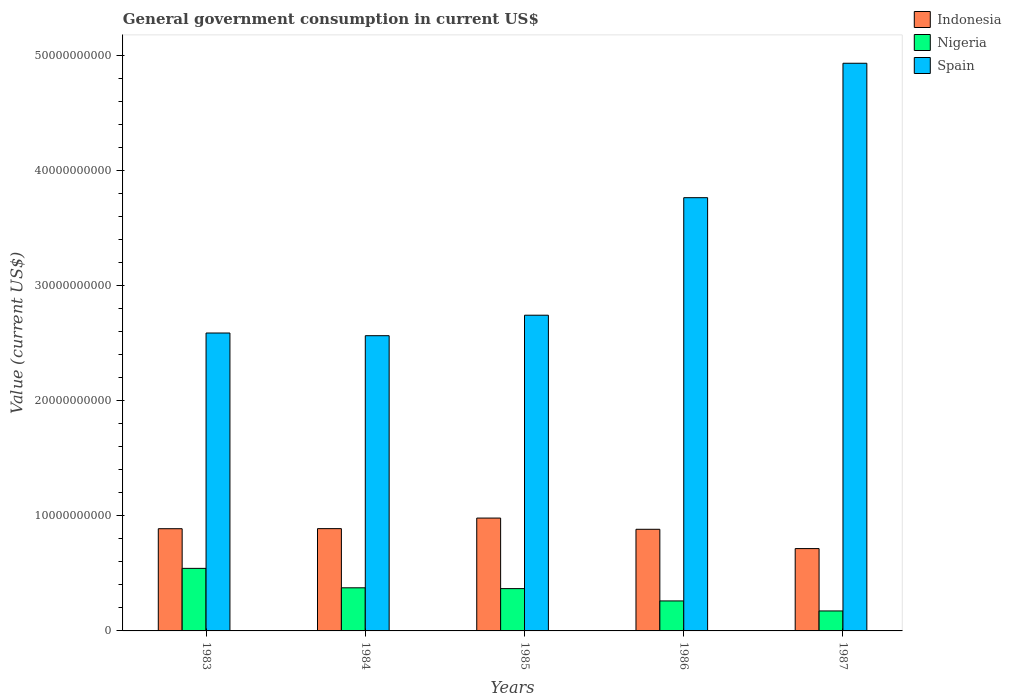How many groups of bars are there?
Ensure brevity in your answer.  5. Are the number of bars on each tick of the X-axis equal?
Your answer should be compact. Yes. How many bars are there on the 3rd tick from the left?
Offer a very short reply. 3. What is the label of the 1st group of bars from the left?
Offer a terse response. 1983. What is the government conusmption in Spain in 1985?
Provide a short and direct response. 2.74e+1. Across all years, what is the maximum government conusmption in Spain?
Your answer should be compact. 4.93e+1. Across all years, what is the minimum government conusmption in Nigeria?
Your answer should be compact. 1.74e+09. In which year was the government conusmption in Nigeria minimum?
Offer a very short reply. 1987. What is the total government conusmption in Indonesia in the graph?
Ensure brevity in your answer.  4.36e+1. What is the difference between the government conusmption in Spain in 1984 and that in 1986?
Ensure brevity in your answer.  -1.20e+1. What is the difference between the government conusmption in Spain in 1986 and the government conusmption in Indonesia in 1987?
Your response must be concise. 3.05e+1. What is the average government conusmption in Indonesia per year?
Your response must be concise. 8.71e+09. In the year 1985, what is the difference between the government conusmption in Indonesia and government conusmption in Nigeria?
Provide a short and direct response. 6.13e+09. What is the ratio of the government conusmption in Spain in 1983 to that in 1987?
Ensure brevity in your answer.  0.52. What is the difference between the highest and the second highest government conusmption in Spain?
Give a very brief answer. 1.17e+1. What is the difference between the highest and the lowest government conusmption in Nigeria?
Offer a very short reply. 3.70e+09. In how many years, is the government conusmption in Indonesia greater than the average government conusmption in Indonesia taken over all years?
Your response must be concise. 4. Is the sum of the government conusmption in Nigeria in 1985 and 1987 greater than the maximum government conusmption in Indonesia across all years?
Offer a very short reply. No. What does the 1st bar from the left in 1987 represents?
Ensure brevity in your answer.  Indonesia. What does the 2nd bar from the right in 1983 represents?
Give a very brief answer. Nigeria. Is it the case that in every year, the sum of the government conusmption in Indonesia and government conusmption in Spain is greater than the government conusmption in Nigeria?
Provide a short and direct response. Yes. Are all the bars in the graph horizontal?
Keep it short and to the point. No. How many years are there in the graph?
Make the answer very short. 5. What is the difference between two consecutive major ticks on the Y-axis?
Make the answer very short. 1.00e+1. Does the graph contain any zero values?
Offer a terse response. No. Does the graph contain grids?
Your answer should be very brief. No. How many legend labels are there?
Give a very brief answer. 3. How are the legend labels stacked?
Provide a short and direct response. Vertical. What is the title of the graph?
Your answer should be very brief. General government consumption in current US$. Does "Dominica" appear as one of the legend labels in the graph?
Make the answer very short. No. What is the label or title of the X-axis?
Ensure brevity in your answer.  Years. What is the label or title of the Y-axis?
Offer a very short reply. Value (current US$). What is the Value (current US$) in Indonesia in 1983?
Keep it short and to the point. 8.88e+09. What is the Value (current US$) in Nigeria in 1983?
Your answer should be compact. 5.44e+09. What is the Value (current US$) in Spain in 1983?
Keep it short and to the point. 2.59e+1. What is the Value (current US$) of Indonesia in 1984?
Offer a terse response. 8.89e+09. What is the Value (current US$) of Nigeria in 1984?
Ensure brevity in your answer.  3.75e+09. What is the Value (current US$) in Spain in 1984?
Your answer should be compact. 2.57e+1. What is the Value (current US$) of Indonesia in 1985?
Provide a succinct answer. 9.81e+09. What is the Value (current US$) in Nigeria in 1985?
Make the answer very short. 3.68e+09. What is the Value (current US$) of Spain in 1985?
Keep it short and to the point. 2.74e+1. What is the Value (current US$) in Indonesia in 1986?
Offer a terse response. 8.83e+09. What is the Value (current US$) in Nigeria in 1986?
Provide a succinct answer. 2.61e+09. What is the Value (current US$) of Spain in 1986?
Provide a succinct answer. 3.77e+1. What is the Value (current US$) in Indonesia in 1987?
Make the answer very short. 7.16e+09. What is the Value (current US$) of Nigeria in 1987?
Your answer should be very brief. 1.74e+09. What is the Value (current US$) in Spain in 1987?
Your answer should be compact. 4.93e+1. Across all years, what is the maximum Value (current US$) of Indonesia?
Your answer should be very brief. 9.81e+09. Across all years, what is the maximum Value (current US$) in Nigeria?
Provide a succinct answer. 5.44e+09. Across all years, what is the maximum Value (current US$) of Spain?
Keep it short and to the point. 4.93e+1. Across all years, what is the minimum Value (current US$) of Indonesia?
Your answer should be very brief. 7.16e+09. Across all years, what is the minimum Value (current US$) in Nigeria?
Your answer should be very brief. 1.74e+09. Across all years, what is the minimum Value (current US$) in Spain?
Give a very brief answer. 2.57e+1. What is the total Value (current US$) in Indonesia in the graph?
Provide a short and direct response. 4.36e+1. What is the total Value (current US$) in Nigeria in the graph?
Your answer should be compact. 1.72e+1. What is the total Value (current US$) in Spain in the graph?
Offer a terse response. 1.66e+11. What is the difference between the Value (current US$) in Indonesia in 1983 and that in 1984?
Your answer should be very brief. -7.40e+06. What is the difference between the Value (current US$) in Nigeria in 1983 and that in 1984?
Your answer should be very brief. 1.69e+09. What is the difference between the Value (current US$) of Spain in 1983 and that in 1984?
Keep it short and to the point. 2.34e+08. What is the difference between the Value (current US$) of Indonesia in 1983 and that in 1985?
Offer a terse response. -9.25e+08. What is the difference between the Value (current US$) of Nigeria in 1983 and that in 1985?
Give a very brief answer. 1.76e+09. What is the difference between the Value (current US$) in Spain in 1983 and that in 1985?
Ensure brevity in your answer.  -1.55e+09. What is the difference between the Value (current US$) in Indonesia in 1983 and that in 1986?
Make the answer very short. 5.03e+07. What is the difference between the Value (current US$) of Nigeria in 1983 and that in 1986?
Ensure brevity in your answer.  2.83e+09. What is the difference between the Value (current US$) in Spain in 1983 and that in 1986?
Offer a very short reply. -1.18e+1. What is the difference between the Value (current US$) of Indonesia in 1983 and that in 1987?
Give a very brief answer. 1.73e+09. What is the difference between the Value (current US$) of Nigeria in 1983 and that in 1987?
Offer a terse response. 3.70e+09. What is the difference between the Value (current US$) in Spain in 1983 and that in 1987?
Make the answer very short. -2.34e+1. What is the difference between the Value (current US$) in Indonesia in 1984 and that in 1985?
Offer a terse response. -9.18e+08. What is the difference between the Value (current US$) in Nigeria in 1984 and that in 1985?
Ensure brevity in your answer.  7.18e+07. What is the difference between the Value (current US$) in Spain in 1984 and that in 1985?
Provide a short and direct response. -1.78e+09. What is the difference between the Value (current US$) of Indonesia in 1984 and that in 1986?
Provide a succinct answer. 5.77e+07. What is the difference between the Value (current US$) of Nigeria in 1984 and that in 1986?
Ensure brevity in your answer.  1.14e+09. What is the difference between the Value (current US$) in Spain in 1984 and that in 1986?
Your answer should be compact. -1.20e+1. What is the difference between the Value (current US$) of Indonesia in 1984 and that in 1987?
Keep it short and to the point. 1.73e+09. What is the difference between the Value (current US$) of Nigeria in 1984 and that in 1987?
Provide a succinct answer. 2.01e+09. What is the difference between the Value (current US$) in Spain in 1984 and that in 1987?
Keep it short and to the point. -2.37e+1. What is the difference between the Value (current US$) in Indonesia in 1985 and that in 1986?
Offer a very short reply. 9.75e+08. What is the difference between the Value (current US$) in Nigeria in 1985 and that in 1986?
Keep it short and to the point. 1.07e+09. What is the difference between the Value (current US$) of Spain in 1985 and that in 1986?
Give a very brief answer. -1.02e+1. What is the difference between the Value (current US$) in Indonesia in 1985 and that in 1987?
Provide a succinct answer. 2.65e+09. What is the difference between the Value (current US$) of Nigeria in 1985 and that in 1987?
Provide a succinct answer. 1.94e+09. What is the difference between the Value (current US$) of Spain in 1985 and that in 1987?
Your answer should be compact. -2.19e+1. What is the difference between the Value (current US$) in Indonesia in 1986 and that in 1987?
Make the answer very short. 1.68e+09. What is the difference between the Value (current US$) of Nigeria in 1986 and that in 1987?
Offer a terse response. 8.71e+08. What is the difference between the Value (current US$) in Spain in 1986 and that in 1987?
Offer a terse response. -1.17e+1. What is the difference between the Value (current US$) in Indonesia in 1983 and the Value (current US$) in Nigeria in 1984?
Provide a short and direct response. 5.14e+09. What is the difference between the Value (current US$) of Indonesia in 1983 and the Value (current US$) of Spain in 1984?
Keep it short and to the point. -1.68e+1. What is the difference between the Value (current US$) of Nigeria in 1983 and the Value (current US$) of Spain in 1984?
Keep it short and to the point. -2.02e+1. What is the difference between the Value (current US$) in Indonesia in 1983 and the Value (current US$) in Nigeria in 1985?
Your response must be concise. 5.21e+09. What is the difference between the Value (current US$) of Indonesia in 1983 and the Value (current US$) of Spain in 1985?
Make the answer very short. -1.86e+1. What is the difference between the Value (current US$) in Nigeria in 1983 and the Value (current US$) in Spain in 1985?
Provide a succinct answer. -2.20e+1. What is the difference between the Value (current US$) of Indonesia in 1983 and the Value (current US$) of Nigeria in 1986?
Offer a very short reply. 6.28e+09. What is the difference between the Value (current US$) of Indonesia in 1983 and the Value (current US$) of Spain in 1986?
Your answer should be very brief. -2.88e+1. What is the difference between the Value (current US$) of Nigeria in 1983 and the Value (current US$) of Spain in 1986?
Your answer should be very brief. -3.22e+1. What is the difference between the Value (current US$) in Indonesia in 1983 and the Value (current US$) in Nigeria in 1987?
Your answer should be compact. 7.15e+09. What is the difference between the Value (current US$) of Indonesia in 1983 and the Value (current US$) of Spain in 1987?
Make the answer very short. -4.05e+1. What is the difference between the Value (current US$) in Nigeria in 1983 and the Value (current US$) in Spain in 1987?
Offer a very short reply. -4.39e+1. What is the difference between the Value (current US$) in Indonesia in 1984 and the Value (current US$) in Nigeria in 1985?
Your answer should be very brief. 5.21e+09. What is the difference between the Value (current US$) of Indonesia in 1984 and the Value (current US$) of Spain in 1985?
Provide a short and direct response. -1.85e+1. What is the difference between the Value (current US$) in Nigeria in 1984 and the Value (current US$) in Spain in 1985?
Your answer should be compact. -2.37e+1. What is the difference between the Value (current US$) in Indonesia in 1984 and the Value (current US$) in Nigeria in 1986?
Offer a terse response. 6.28e+09. What is the difference between the Value (current US$) of Indonesia in 1984 and the Value (current US$) of Spain in 1986?
Give a very brief answer. -2.88e+1. What is the difference between the Value (current US$) of Nigeria in 1984 and the Value (current US$) of Spain in 1986?
Ensure brevity in your answer.  -3.39e+1. What is the difference between the Value (current US$) of Indonesia in 1984 and the Value (current US$) of Nigeria in 1987?
Ensure brevity in your answer.  7.15e+09. What is the difference between the Value (current US$) of Indonesia in 1984 and the Value (current US$) of Spain in 1987?
Give a very brief answer. -4.04e+1. What is the difference between the Value (current US$) in Nigeria in 1984 and the Value (current US$) in Spain in 1987?
Your answer should be very brief. -4.56e+1. What is the difference between the Value (current US$) in Indonesia in 1985 and the Value (current US$) in Nigeria in 1986?
Make the answer very short. 7.20e+09. What is the difference between the Value (current US$) in Indonesia in 1985 and the Value (current US$) in Spain in 1986?
Provide a short and direct response. -2.78e+1. What is the difference between the Value (current US$) in Nigeria in 1985 and the Value (current US$) in Spain in 1986?
Offer a very short reply. -3.40e+1. What is the difference between the Value (current US$) in Indonesia in 1985 and the Value (current US$) in Nigeria in 1987?
Make the answer very short. 8.07e+09. What is the difference between the Value (current US$) in Indonesia in 1985 and the Value (current US$) in Spain in 1987?
Offer a very short reply. -3.95e+1. What is the difference between the Value (current US$) of Nigeria in 1985 and the Value (current US$) of Spain in 1987?
Give a very brief answer. -4.57e+1. What is the difference between the Value (current US$) in Indonesia in 1986 and the Value (current US$) in Nigeria in 1987?
Provide a succinct answer. 7.10e+09. What is the difference between the Value (current US$) of Indonesia in 1986 and the Value (current US$) of Spain in 1987?
Give a very brief answer. -4.05e+1. What is the difference between the Value (current US$) in Nigeria in 1986 and the Value (current US$) in Spain in 1987?
Give a very brief answer. -4.67e+1. What is the average Value (current US$) of Indonesia per year?
Your answer should be compact. 8.71e+09. What is the average Value (current US$) of Nigeria per year?
Provide a succinct answer. 3.44e+09. What is the average Value (current US$) in Spain per year?
Ensure brevity in your answer.  3.32e+1. In the year 1983, what is the difference between the Value (current US$) in Indonesia and Value (current US$) in Nigeria?
Offer a terse response. 3.45e+09. In the year 1983, what is the difference between the Value (current US$) in Indonesia and Value (current US$) in Spain?
Your response must be concise. -1.70e+1. In the year 1983, what is the difference between the Value (current US$) of Nigeria and Value (current US$) of Spain?
Provide a succinct answer. -2.05e+1. In the year 1984, what is the difference between the Value (current US$) in Indonesia and Value (current US$) in Nigeria?
Provide a short and direct response. 5.14e+09. In the year 1984, what is the difference between the Value (current US$) of Indonesia and Value (current US$) of Spain?
Give a very brief answer. -1.68e+1. In the year 1984, what is the difference between the Value (current US$) of Nigeria and Value (current US$) of Spain?
Your answer should be compact. -2.19e+1. In the year 1985, what is the difference between the Value (current US$) of Indonesia and Value (current US$) of Nigeria?
Offer a terse response. 6.13e+09. In the year 1985, what is the difference between the Value (current US$) in Indonesia and Value (current US$) in Spain?
Keep it short and to the point. -1.76e+1. In the year 1985, what is the difference between the Value (current US$) of Nigeria and Value (current US$) of Spain?
Your response must be concise. -2.38e+1. In the year 1986, what is the difference between the Value (current US$) of Indonesia and Value (current US$) of Nigeria?
Make the answer very short. 6.23e+09. In the year 1986, what is the difference between the Value (current US$) in Indonesia and Value (current US$) in Spain?
Provide a short and direct response. -2.88e+1. In the year 1986, what is the difference between the Value (current US$) in Nigeria and Value (current US$) in Spain?
Your answer should be very brief. -3.50e+1. In the year 1987, what is the difference between the Value (current US$) of Indonesia and Value (current US$) of Nigeria?
Your answer should be very brief. 5.42e+09. In the year 1987, what is the difference between the Value (current US$) in Indonesia and Value (current US$) in Spain?
Your answer should be very brief. -4.22e+1. In the year 1987, what is the difference between the Value (current US$) of Nigeria and Value (current US$) of Spain?
Keep it short and to the point. -4.76e+1. What is the ratio of the Value (current US$) in Nigeria in 1983 to that in 1984?
Make the answer very short. 1.45. What is the ratio of the Value (current US$) in Spain in 1983 to that in 1984?
Ensure brevity in your answer.  1.01. What is the ratio of the Value (current US$) in Indonesia in 1983 to that in 1985?
Ensure brevity in your answer.  0.91. What is the ratio of the Value (current US$) in Nigeria in 1983 to that in 1985?
Offer a terse response. 1.48. What is the ratio of the Value (current US$) of Spain in 1983 to that in 1985?
Provide a succinct answer. 0.94. What is the ratio of the Value (current US$) of Indonesia in 1983 to that in 1986?
Offer a very short reply. 1.01. What is the ratio of the Value (current US$) in Nigeria in 1983 to that in 1986?
Offer a very short reply. 2.09. What is the ratio of the Value (current US$) in Spain in 1983 to that in 1986?
Offer a terse response. 0.69. What is the ratio of the Value (current US$) of Indonesia in 1983 to that in 1987?
Offer a terse response. 1.24. What is the ratio of the Value (current US$) of Nigeria in 1983 to that in 1987?
Give a very brief answer. 3.13. What is the ratio of the Value (current US$) in Spain in 1983 to that in 1987?
Provide a succinct answer. 0.52. What is the ratio of the Value (current US$) in Indonesia in 1984 to that in 1985?
Make the answer very short. 0.91. What is the ratio of the Value (current US$) in Nigeria in 1984 to that in 1985?
Offer a terse response. 1.02. What is the ratio of the Value (current US$) of Spain in 1984 to that in 1985?
Make the answer very short. 0.94. What is the ratio of the Value (current US$) in Nigeria in 1984 to that in 1986?
Give a very brief answer. 1.44. What is the ratio of the Value (current US$) of Spain in 1984 to that in 1986?
Your response must be concise. 0.68. What is the ratio of the Value (current US$) of Indonesia in 1984 to that in 1987?
Keep it short and to the point. 1.24. What is the ratio of the Value (current US$) in Nigeria in 1984 to that in 1987?
Your answer should be very brief. 2.16. What is the ratio of the Value (current US$) in Spain in 1984 to that in 1987?
Make the answer very short. 0.52. What is the ratio of the Value (current US$) in Indonesia in 1985 to that in 1986?
Your answer should be compact. 1.11. What is the ratio of the Value (current US$) in Nigeria in 1985 to that in 1986?
Give a very brief answer. 1.41. What is the ratio of the Value (current US$) in Spain in 1985 to that in 1986?
Provide a short and direct response. 0.73. What is the ratio of the Value (current US$) of Indonesia in 1985 to that in 1987?
Provide a short and direct response. 1.37. What is the ratio of the Value (current US$) of Nigeria in 1985 to that in 1987?
Ensure brevity in your answer.  2.12. What is the ratio of the Value (current US$) of Spain in 1985 to that in 1987?
Give a very brief answer. 0.56. What is the ratio of the Value (current US$) in Indonesia in 1986 to that in 1987?
Your answer should be compact. 1.23. What is the ratio of the Value (current US$) of Nigeria in 1986 to that in 1987?
Your answer should be very brief. 1.5. What is the ratio of the Value (current US$) of Spain in 1986 to that in 1987?
Provide a succinct answer. 0.76. What is the difference between the highest and the second highest Value (current US$) of Indonesia?
Your response must be concise. 9.18e+08. What is the difference between the highest and the second highest Value (current US$) of Nigeria?
Make the answer very short. 1.69e+09. What is the difference between the highest and the second highest Value (current US$) of Spain?
Your answer should be compact. 1.17e+1. What is the difference between the highest and the lowest Value (current US$) of Indonesia?
Offer a terse response. 2.65e+09. What is the difference between the highest and the lowest Value (current US$) of Nigeria?
Give a very brief answer. 3.70e+09. What is the difference between the highest and the lowest Value (current US$) of Spain?
Your answer should be very brief. 2.37e+1. 